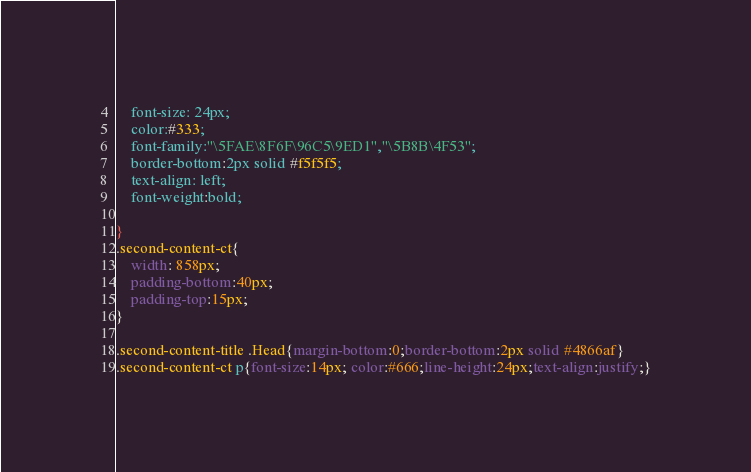<code> <loc_0><loc_0><loc_500><loc_500><_CSS_>    font-size: 24px;
    color:#333;
    font-family:"\5FAE\8F6F\96C5\9ED1","\5B8B\4F53";
    border-bottom:2px solid #f5f5f5;
    text-align: left;
    font-weight:bold;

}
.second-content-ct{
    width: 858px;
    padding-bottom:40px;
    padding-top:15px;
}

.second-content-title .Head{margin-bottom:0;border-bottom:2px solid #4866af}
.second-content-ct p{font-size:14px; color:#666;line-height:24px;text-align:justify;}
</code> 